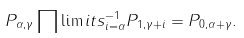Convert formula to latex. <formula><loc_0><loc_0><loc_500><loc_500>P _ { \alpha , \gamma } \prod \lim i t s _ { i = \alpha } ^ { - 1 } P _ { 1 , \gamma + i } = P _ { 0 , \alpha + \gamma } .</formula> 